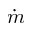Convert formula to latex. <formula><loc_0><loc_0><loc_500><loc_500>\dot { m }</formula> 